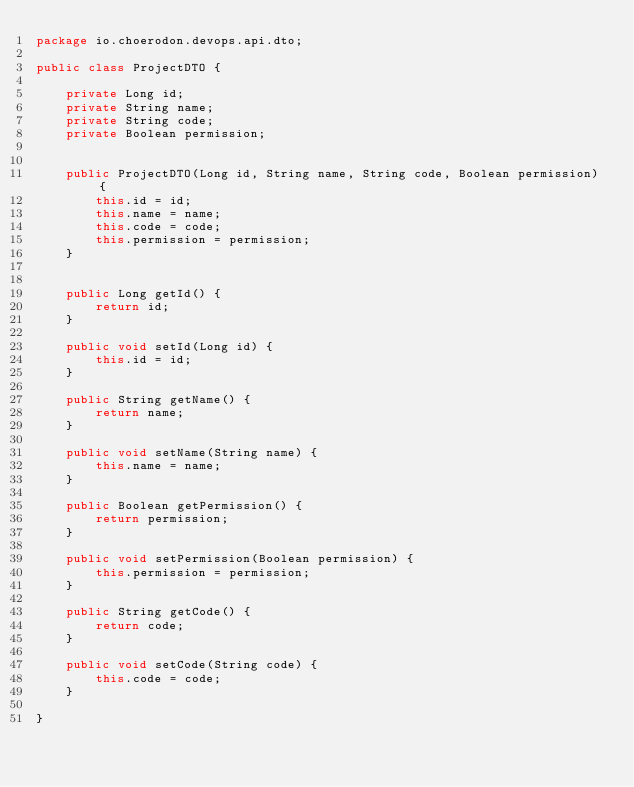Convert code to text. <code><loc_0><loc_0><loc_500><loc_500><_Java_>package io.choerodon.devops.api.dto;

public class ProjectDTO {

    private Long id;
    private String name;
    private String code;
    private Boolean permission;


    public ProjectDTO(Long id, String name, String code, Boolean permission) {
        this.id = id;
        this.name = name;
        this.code = code;
        this.permission = permission;
    }


    public Long getId() {
        return id;
    }

    public void setId(Long id) {
        this.id = id;
    }

    public String getName() {
        return name;
    }

    public void setName(String name) {
        this.name = name;
    }

    public Boolean getPermission() {
        return permission;
    }

    public void setPermission(Boolean permission) {
        this.permission = permission;
    }

    public String getCode() {
        return code;
    }

    public void setCode(String code) {
        this.code = code;
    }

}
</code> 